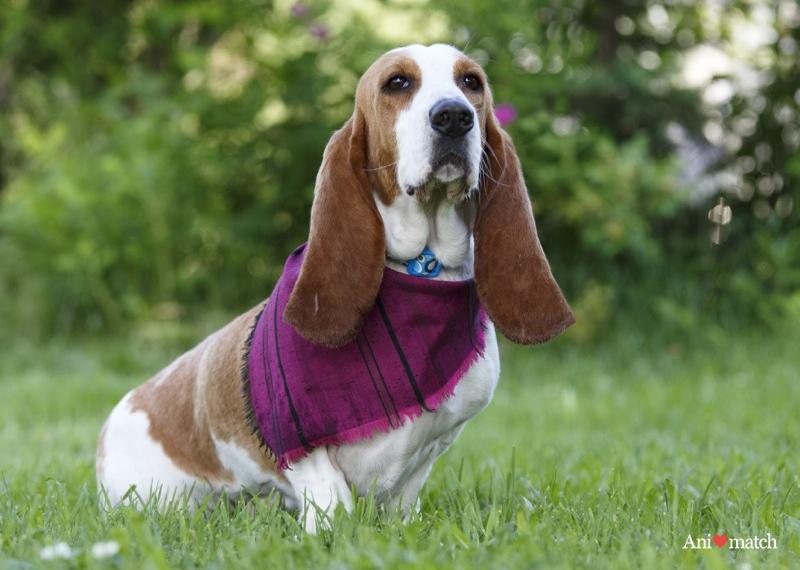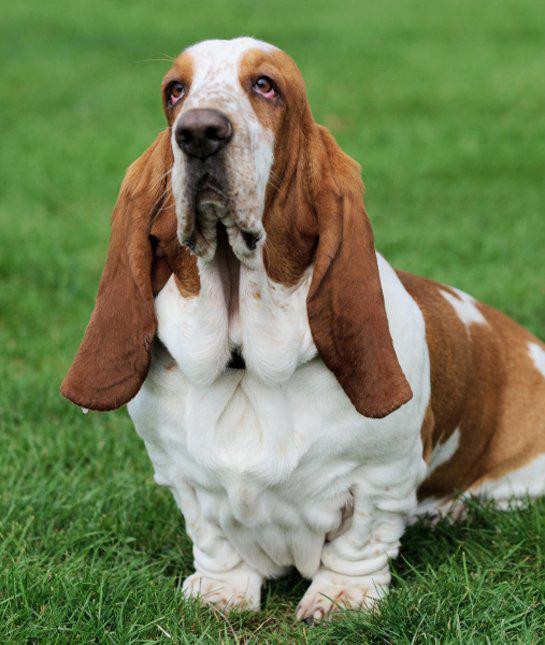The first image is the image on the left, the second image is the image on the right. For the images shown, is this caption "The dog in the image on the right is running toward the camera." true? Answer yes or no. No. 